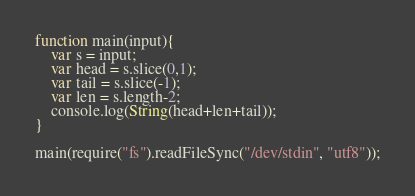<code> <loc_0><loc_0><loc_500><loc_500><_JavaScript_>function main(input){
    var s = input;
    var head = s.slice(0,1);
    var tail = s.slice(-1);
    var len = s.length-2;
    console.log(String(head+len+tail));
}

main(require("fs").readFileSync("/dev/stdin", "utf8"));</code> 